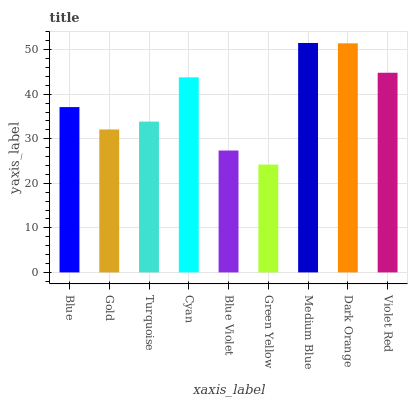Is Green Yellow the minimum?
Answer yes or no. Yes. Is Medium Blue the maximum?
Answer yes or no. Yes. Is Gold the minimum?
Answer yes or no. No. Is Gold the maximum?
Answer yes or no. No. Is Blue greater than Gold?
Answer yes or no. Yes. Is Gold less than Blue?
Answer yes or no. Yes. Is Gold greater than Blue?
Answer yes or no. No. Is Blue less than Gold?
Answer yes or no. No. Is Blue the high median?
Answer yes or no. Yes. Is Blue the low median?
Answer yes or no. Yes. Is Turquoise the high median?
Answer yes or no. No. Is Green Yellow the low median?
Answer yes or no. No. 